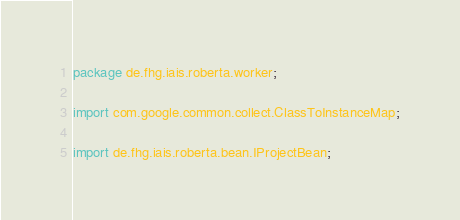<code> <loc_0><loc_0><loc_500><loc_500><_Java_>package de.fhg.iais.roberta.worker;

import com.google.common.collect.ClassToInstanceMap;

import de.fhg.iais.roberta.bean.IProjectBean;</code> 